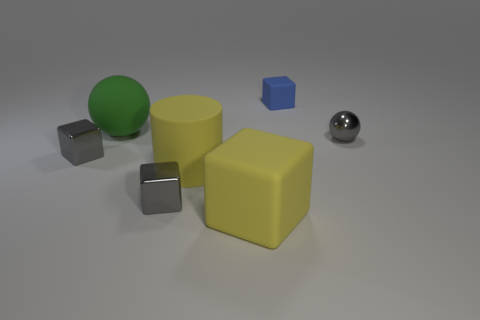Do the large yellow cylinder and the tiny gray sphere have the same material?
Give a very brief answer. No. How many gray metallic things are there?
Provide a short and direct response. 3. There is a rubber cube that is in front of the tiny object behind the gray object that is on the right side of the small blue block; what color is it?
Offer a terse response. Yellow. Is the large cylinder the same color as the big rubber block?
Your answer should be compact. Yes. What number of tiny metallic objects are right of the blue object and left of the rubber cylinder?
Provide a succinct answer. 0. How many metal things are either tiny purple cylinders or big objects?
Provide a short and direct response. 0. There is a blue object behind the yellow matte thing right of the large cylinder; what is its material?
Your answer should be compact. Rubber. The rubber object that is the same color as the large rubber block is what shape?
Offer a terse response. Cylinder. There is a green object that is the same size as the yellow cylinder; what shape is it?
Provide a short and direct response. Sphere. Is the number of green rubber spheres less than the number of gray metallic cubes?
Offer a very short reply. Yes. 